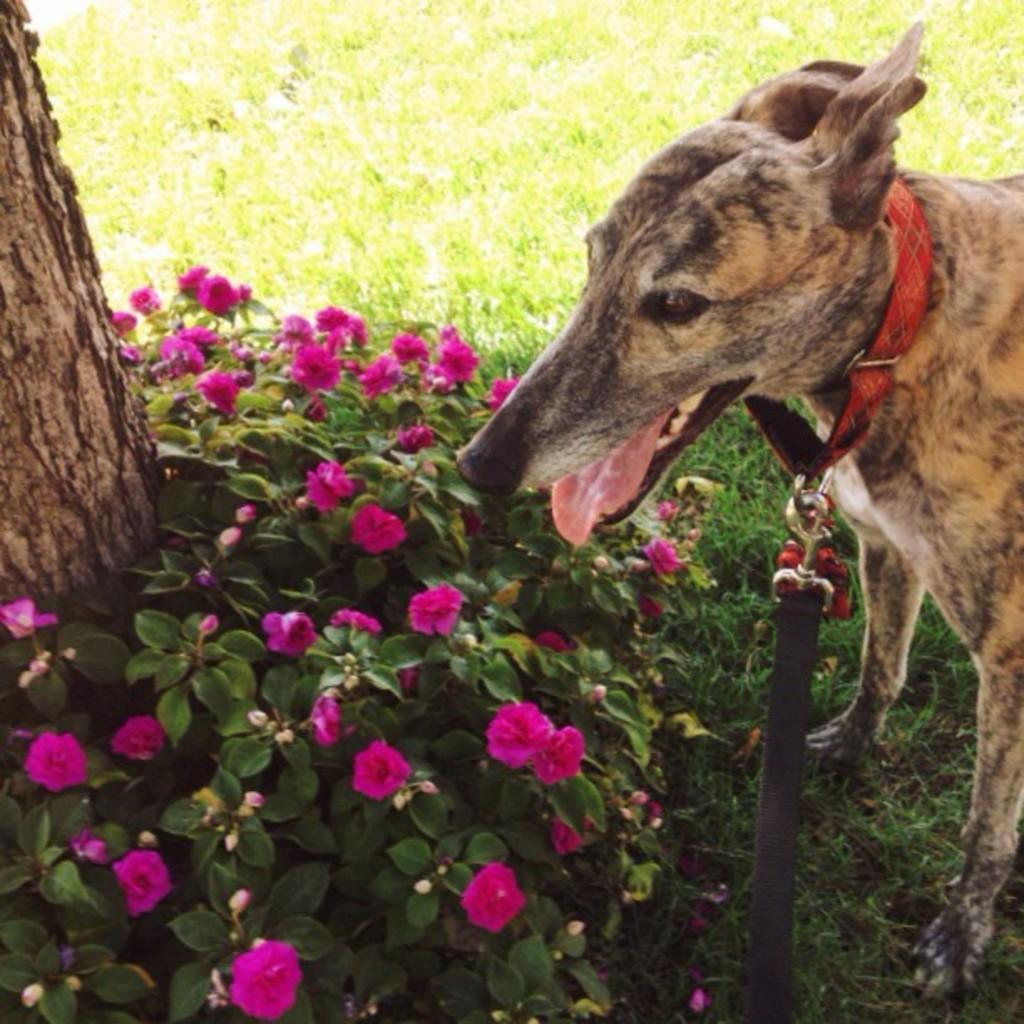What is located in the front of the image? There are flowers and a dog in the front of the image. What type of vegetation can be seen in the center of the image? There is grass on the ground in the center of the image. What can be seen on the left side of the image? There is a tree trunk on the left side of the image. How many beads are hanging from the tree trunk in the image? There are no beads present in the image; it features flowers, a dog, grass, and a tree trunk. What type of connection can be seen between the flowers and the dog in the image? There is no visible connection between the flowers and the dog in the image; they are simply located near each other. 